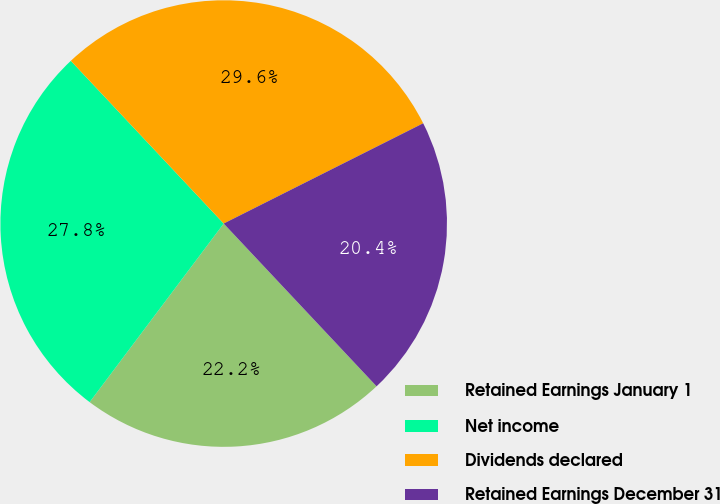Convert chart. <chart><loc_0><loc_0><loc_500><loc_500><pie_chart><fcel>Retained Earnings January 1<fcel>Net income<fcel>Dividends declared<fcel>Retained Earnings December 31<nl><fcel>22.25%<fcel>27.75%<fcel>29.59%<fcel>20.41%<nl></chart> 